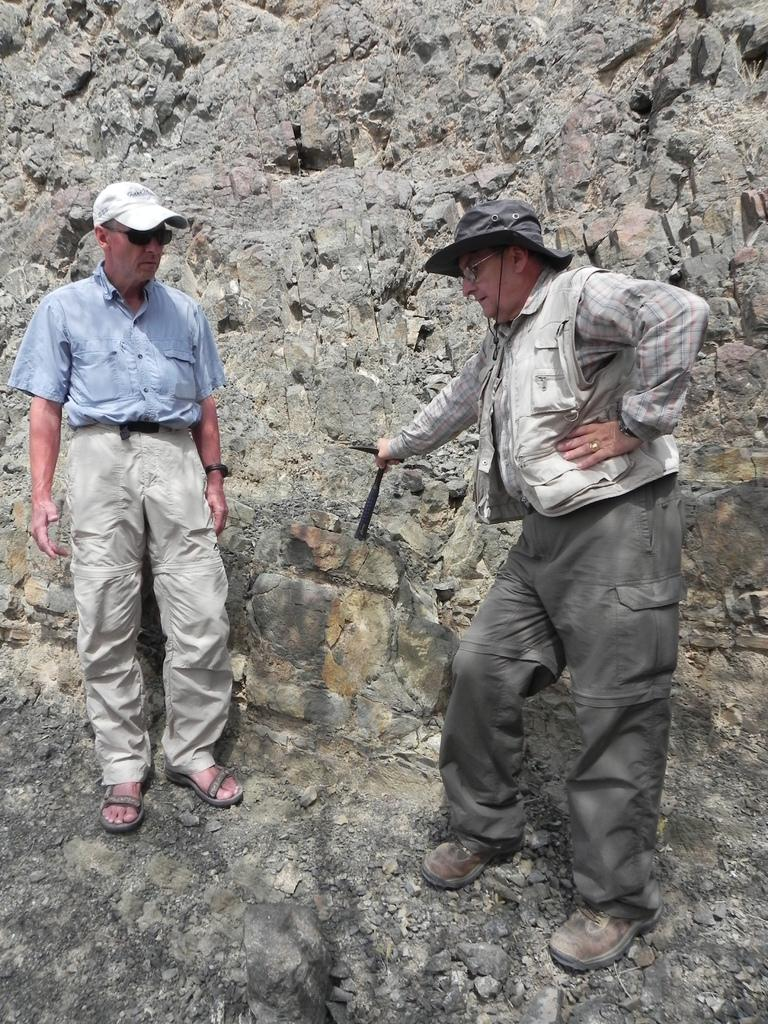What are the men in the image doing? The men are standing on a rock in the image. What are the men wearing on their heads? The men are wearing caps on their heads. What is one of the men holding in his hand? One of the men is holding a metal instrument in his hand. What type of heart-shaped substance can be seen in the image? There is no heart-shaped substance present in the image. 